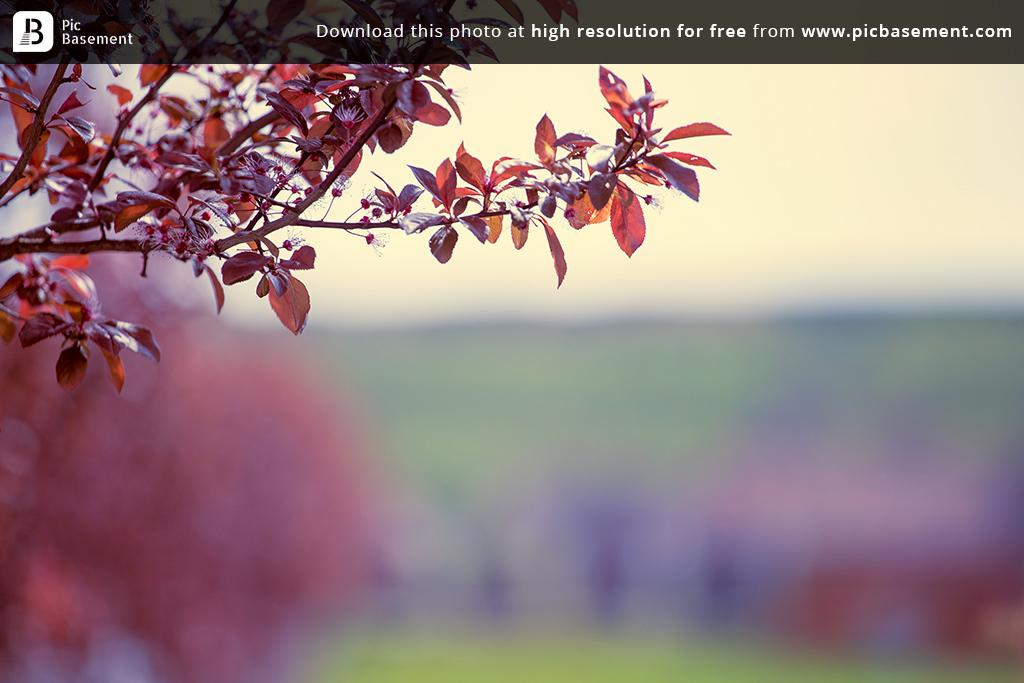What type of plant elements can be seen in the image? There are stems and leaves in the image. Can you describe the background of the image? The background of the image is blurry. Is there any text present in the image? Yes, there is some text written on a black bar at the top of the image. What type of cheese is being grated in the image? There is no cheese or grating activity present in the image. What time of day is it in the image? The time of day cannot be determined from the image, as there are no clues to suggest whether it is morning, afternoon, or evening. 